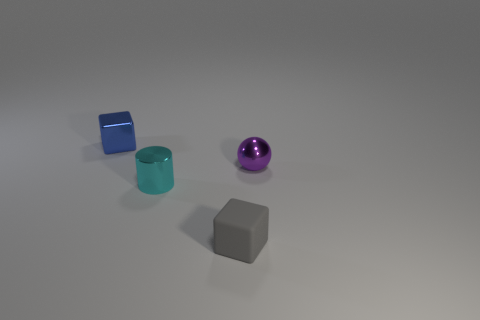Are there any large brown objects made of the same material as the cyan object?
Your response must be concise. No. Are there any tiny gray objects left of the shiny block to the left of the small purple ball?
Offer a very short reply. No. There is a cube to the left of the matte thing; is it the same size as the matte thing?
Provide a short and direct response. Yes. What number of big objects are blue objects or brown rubber cylinders?
Your answer should be very brief. 0. There is a thing that is both behind the small cyan cylinder and on the right side of the small cyan cylinder; how big is it?
Ensure brevity in your answer.  Small. What number of tiny metal cylinders are on the right side of the tiny blue metallic thing?
Provide a succinct answer. 1. There is a metallic thing that is both behind the shiny cylinder and right of the tiny blue thing; what is its shape?
Provide a short and direct response. Sphere. What number of blocks are small red shiny things or tiny things?
Your answer should be compact. 2. Is the number of metal blocks right of the gray rubber block less than the number of cyan matte cubes?
Ensure brevity in your answer.  No. There is a object that is in front of the metal ball and on the left side of the small rubber block; what color is it?
Give a very brief answer. Cyan. 